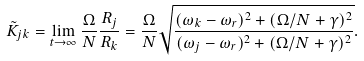Convert formula to latex. <formula><loc_0><loc_0><loc_500><loc_500>\tilde { K } _ { j k } = \lim _ { t \to \infty } \frac { \Omega } { N } \frac { R _ { j } } { R _ { k } } = \frac { \Omega } { N } \sqrt { \frac { ( \omega _ { k } - \omega _ { r } ) ^ { 2 } + ( \Omega / N + \gamma ) ^ { 2 } } { ( \omega _ { j } - \omega _ { r } ) ^ { 2 } + ( \Omega / N + \gamma ) ^ { 2 } } } .</formula> 